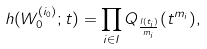Convert formula to latex. <formula><loc_0><loc_0><loc_500><loc_500>h ( W _ { 0 } ^ { ( i _ { 0 } ) } ; t ) = \prod _ { i \in I } Q _ { \frac { l ( t _ { i } ) } { m _ { i } } } ( t ^ { m _ { i } } ) ,</formula> 